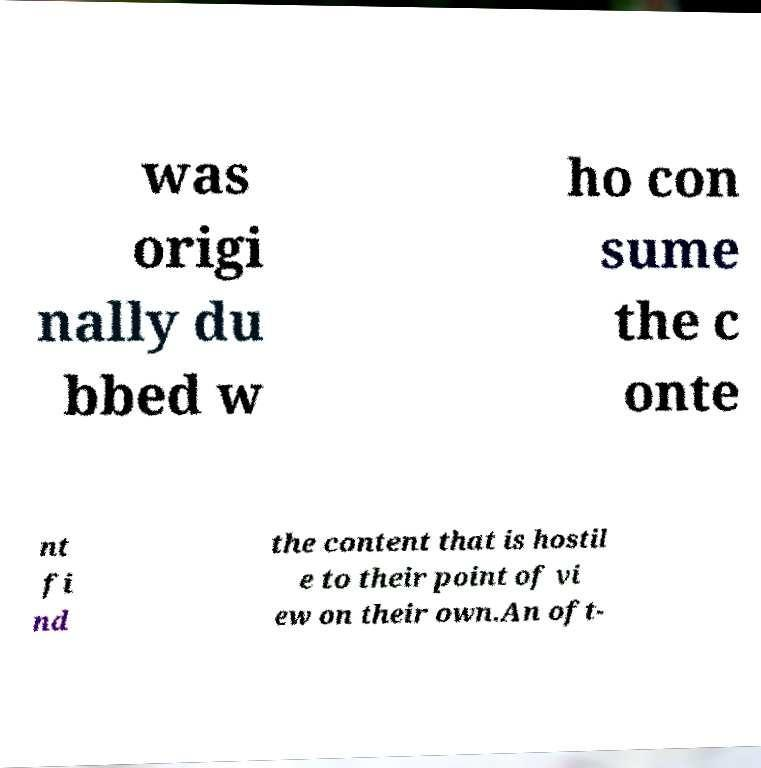For documentation purposes, I need the text within this image transcribed. Could you provide that? was origi nally du bbed w ho con sume the c onte nt fi nd the content that is hostil e to their point of vi ew on their own.An oft- 